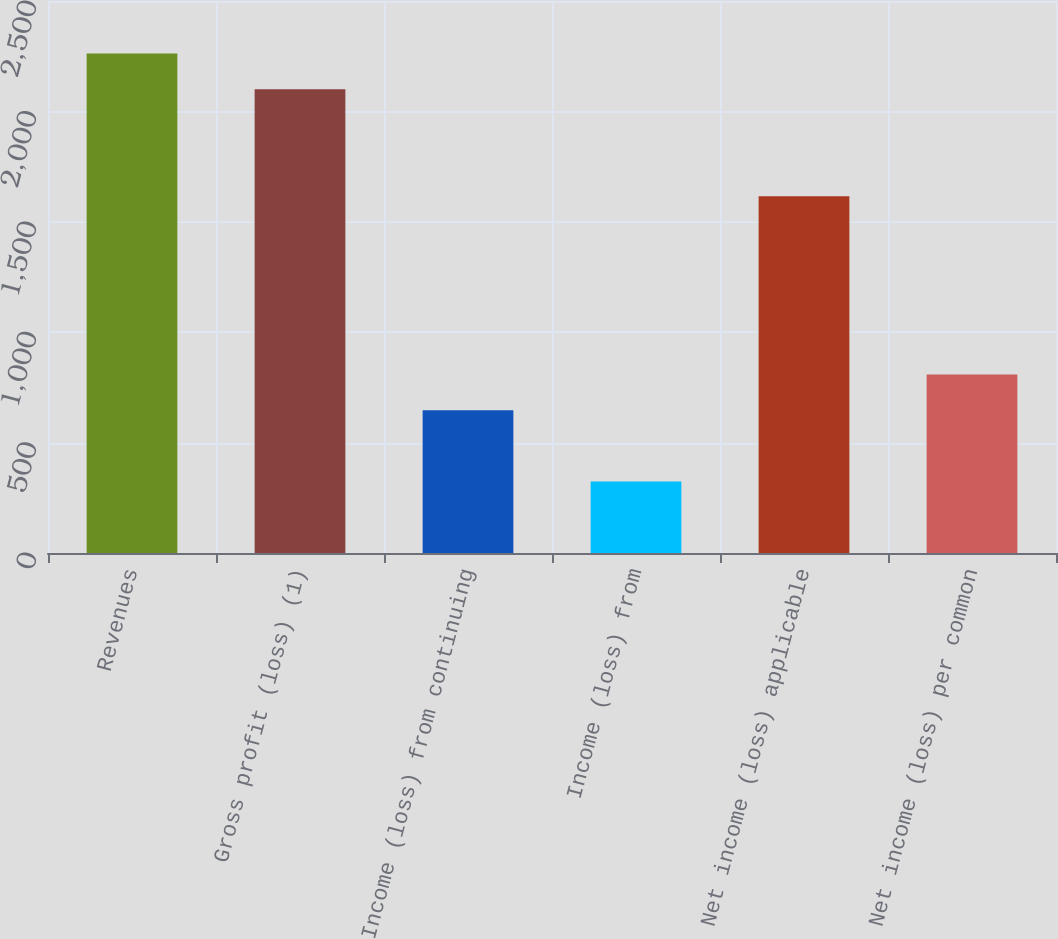<chart> <loc_0><loc_0><loc_500><loc_500><bar_chart><fcel>Revenues<fcel>Gross profit (loss) (1)<fcel>Income (loss) from continuing<fcel>Income (loss) from<fcel>Net income (loss) applicable<fcel>Net income (loss) per common<nl><fcel>2262.36<fcel>2100.77<fcel>646.46<fcel>323.28<fcel>1616<fcel>808.05<nl></chart> 